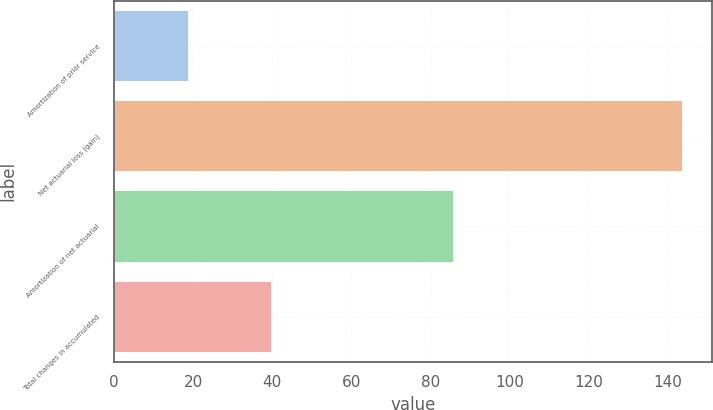<chart> <loc_0><loc_0><loc_500><loc_500><bar_chart><fcel>Amortization of prior service<fcel>Net actuarial loss (gain)<fcel>Amortization of net actuarial<fcel>Total changes in accumulated<nl><fcel>19<fcel>144<fcel>86<fcel>40<nl></chart> 